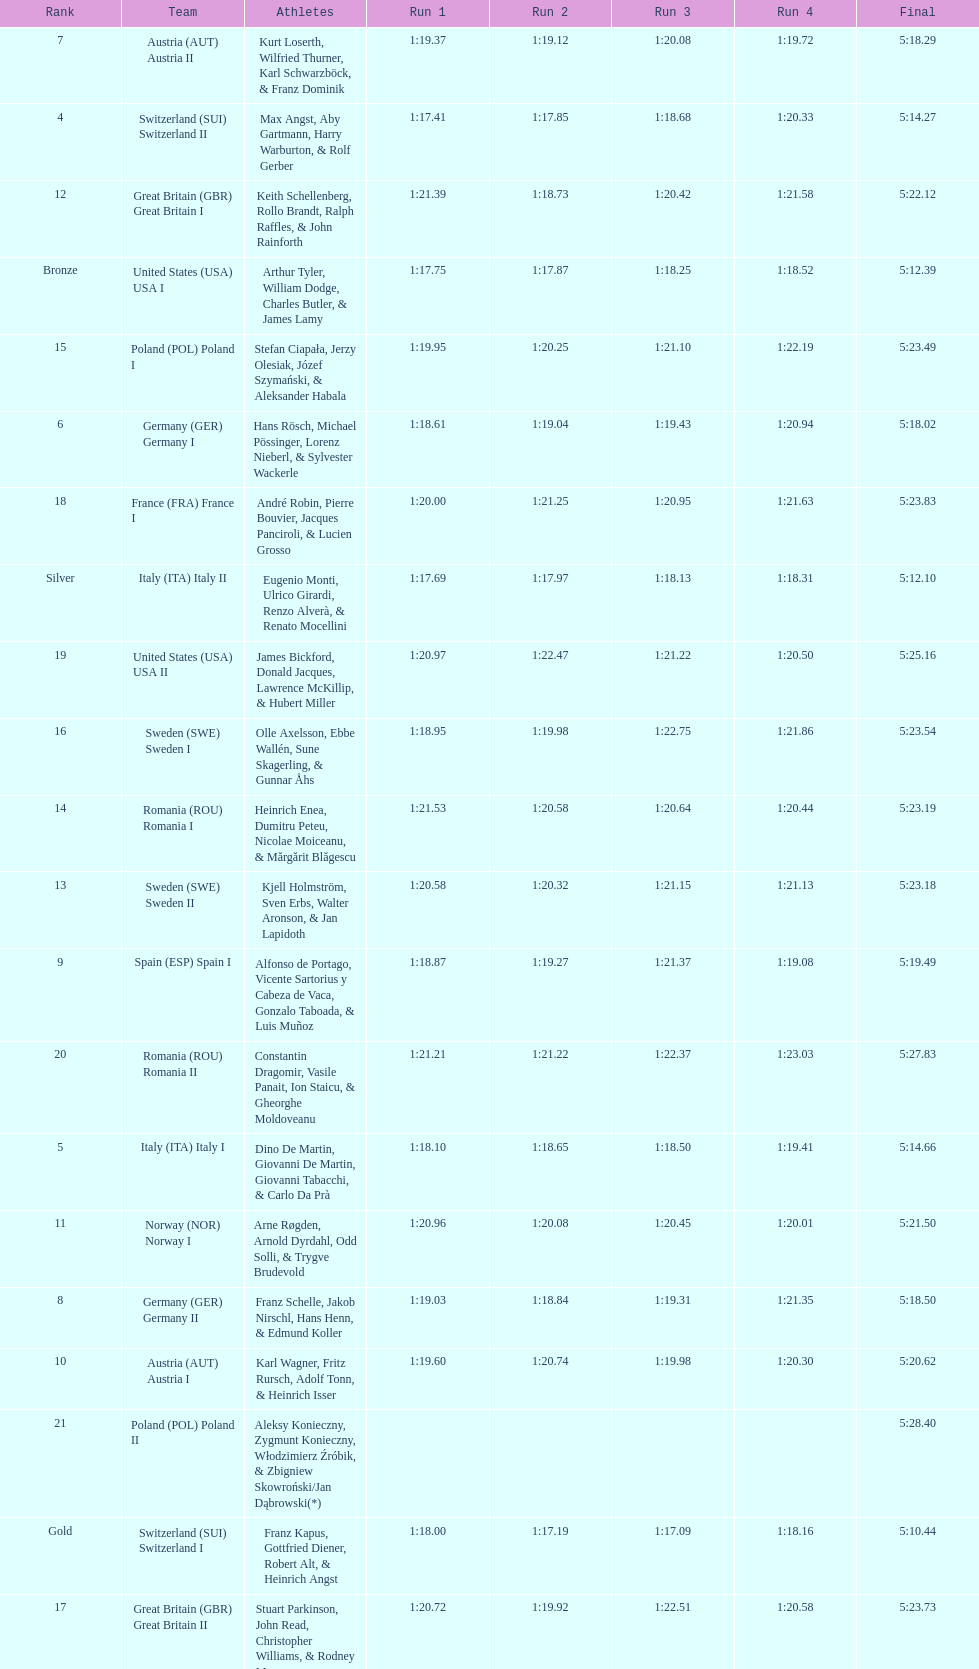What team comes after italy (ita) italy i? Germany I. 